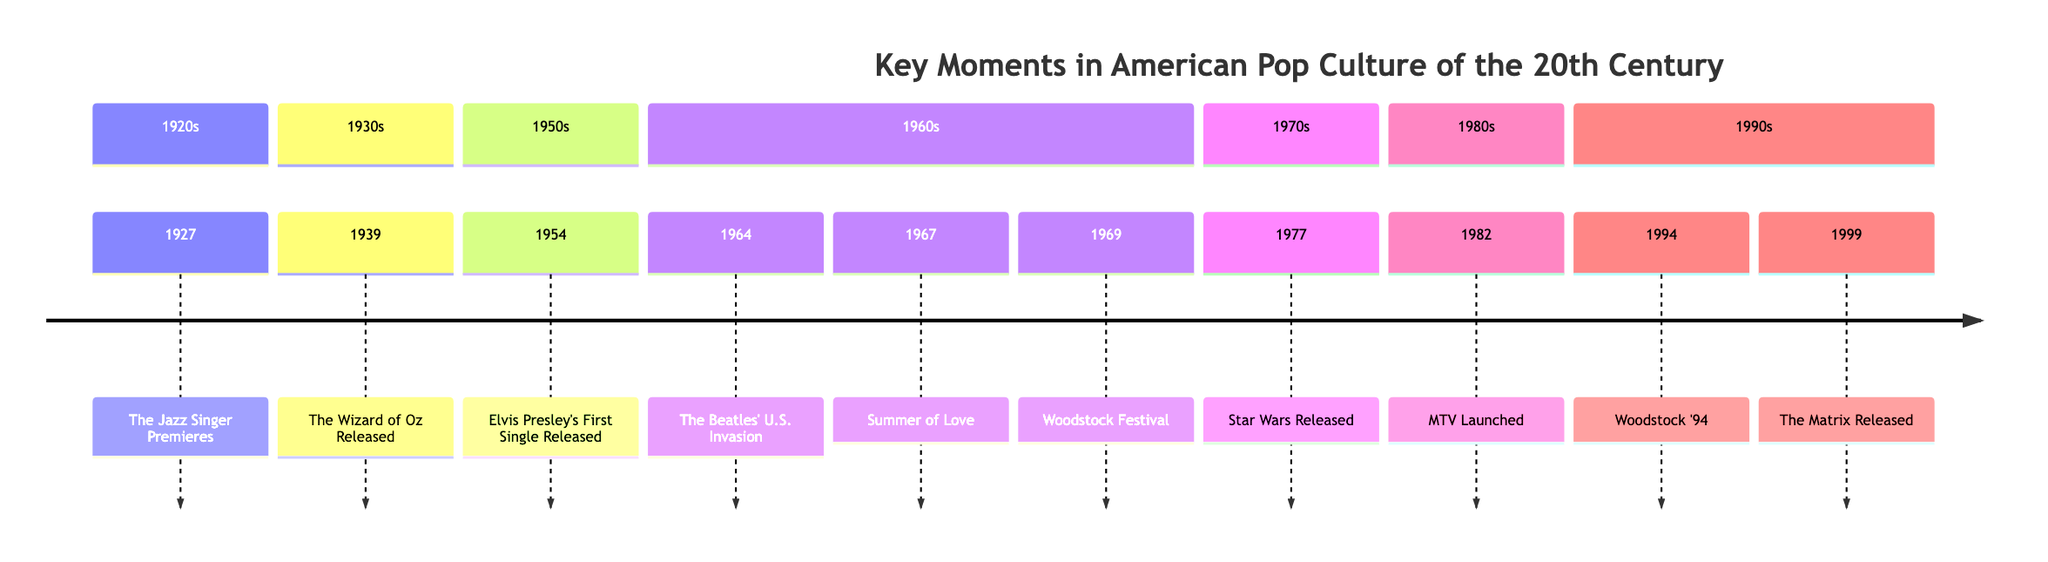What event marks the beginning of the era of 'talkies'? According to the timeline, the event that marks the beginning of the era of 'talkies' is 'The Jazz Singer Premieres' in 1927.
Answer: The Jazz Singer Premieres Which iconic film was released in 1939? The timeline shows that 'The Wizard of Oz Released' is the iconic film from 1939.
Answer: The Wizard of Oz Released What year did Elvis Presley release his first single? From the timeline information, Elvis Presley released his first single in 1954.
Answer: 1954 Which event features performances by Jimi Hendrix and The Grateful Dead? The timeline indicates that the 'Woodstock Festival' in 1969 features performances by Jimi Hendrix and The Grateful Dead, making it a significant event.
Answer: Woodstock Festival What transformative television network was launched in 1982? The timeline specifies that 'MTV Launched' in 1982 transformed the music industry with its focus on music videos.
Answer: MTV Launched How many key moments are listed in the timeline? By reviewing the timeline, I count a total of 10 key moments, as each event is specified with a corresponding year.
Answer: 10 What was a significant cultural phenomenon established by the release of 'Star Wars'? The timeline highlights that the release of 'Star Wars' in 1977 established a massive pop culture phenomenon and revolutionized the film industry.
Answer: Massive pop culture phenomenon Which decade does the event 'Summer of Love' belong to? As per the timeline, the 'Summer of Love' event is described within the 1960s section, indicating that it belongs to that decade.
Answer: 1960s In what year was 'The Matrix' released? The timeline clearly shows that 'The Matrix Released' in 1999.
Answer: 1999 